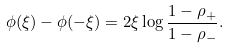<formula> <loc_0><loc_0><loc_500><loc_500>\phi ( \xi ) - \phi ( - \xi ) = 2 \xi \log \frac { 1 - \rho _ { + } } { 1 - \rho _ { - } } .</formula> 